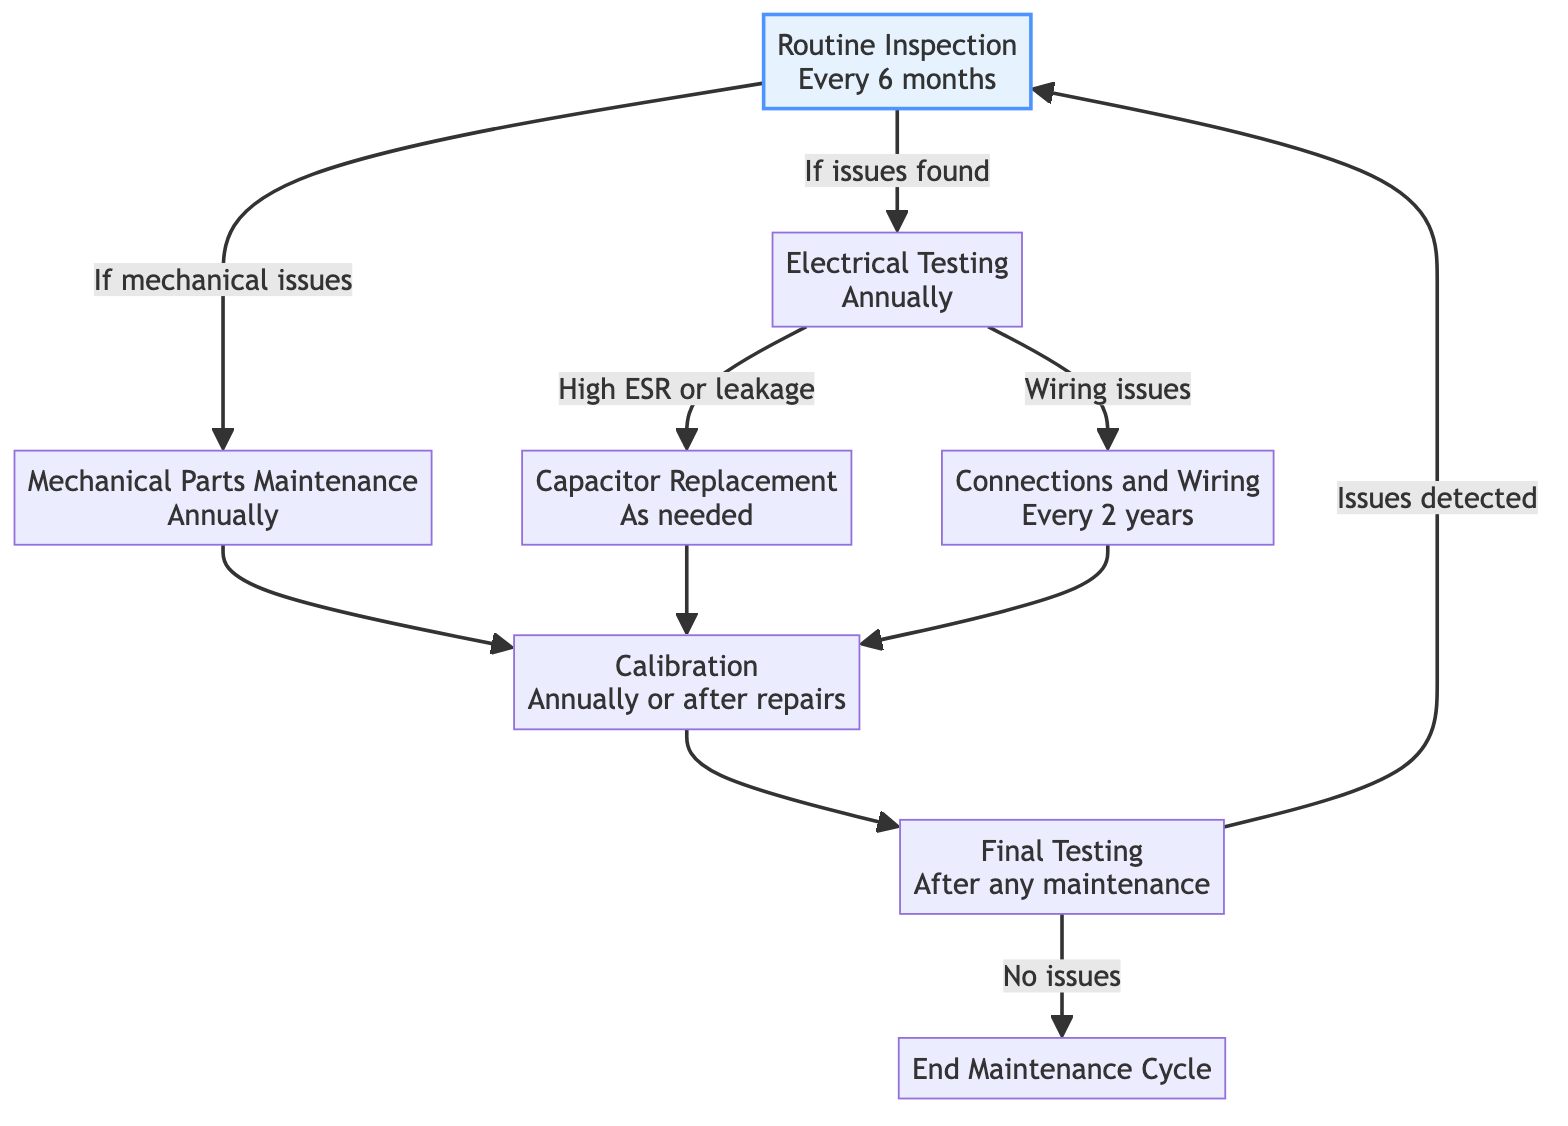What is the frequency of Routine Inspection? The diagram specifies that Routine Inspection occurs every 6 months. This can be found directly from the node labeled "Routine Inspection".
Answer: Every 6 months How many maintenance tasks are listed under Electrical Testing? Under the Electrical Testing node, there are three tasks outlined. This is counted by enumerating the listed tasks as "Test capacitors for leakage and ESR", "Voltage measurement at key points", and "Resistance checks on connections and wiring".
Answer: 3 What happens if issues are found during Routine Inspection? According to the flowchart, if issues are detected during Routine Inspection, it leads to the Electrical Testing node. This indicates that further testing will be performed to identify any electrical issues.
Answer: Electrical Testing Under what condition is Capacitor Replacement initiated? The flowchart indicates that Capacitor Replacement is initiated when there is high ESR or leakage in the capacitors. This condition is specifically listed in the node for Capacitor Replacement.
Answer: High ESR or leakage What is the purpose of the Final Testing stage? The Final Testing stage serves three main purposes: conducting listening tests, measuring performance metrics, and ensuring the functionality of controls and features. This is directly stated in the tasks listed under Final Testing.
Answer: Verify performance What frequency check is performed on Connections and Wiring? The diagram specifies that Connections and Wiring are checked every 2 years. This information is found directly in the node dedicated to Connections and Wiring maintenance.
Answer: Every 2 years What is the relationship between Mechanical Parts Maintenance and Calibration? After performing Mechanical Parts Maintenance, the next step is Calibration, which is indicated by an arrow leading from the Mechanical Parts Maintenance node to the Calibration node. This shows that Calibration follows Maintenance of Mechanical Parts.
Answer: Calibration follows What should be done after any maintenance task? After any maintenance task, Final Testing should be conducted, as indicated by the flowchart arrow pointing from various maintenance tasks to the Final Testing stage.
Answer: Final Testing What task is performed annually or after major repairs according to the diagram? The task performed annually or after major repairs is Calibration, which is explicitly mentioned in the node related to Calibration maintenance.
Answer: Calibration 